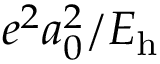<formula> <loc_0><loc_0><loc_500><loc_500>e ^ { 2 } a _ { 0 } ^ { 2 } / E _ { h }</formula> 